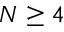<formula> <loc_0><loc_0><loc_500><loc_500>N \geq 4</formula> 